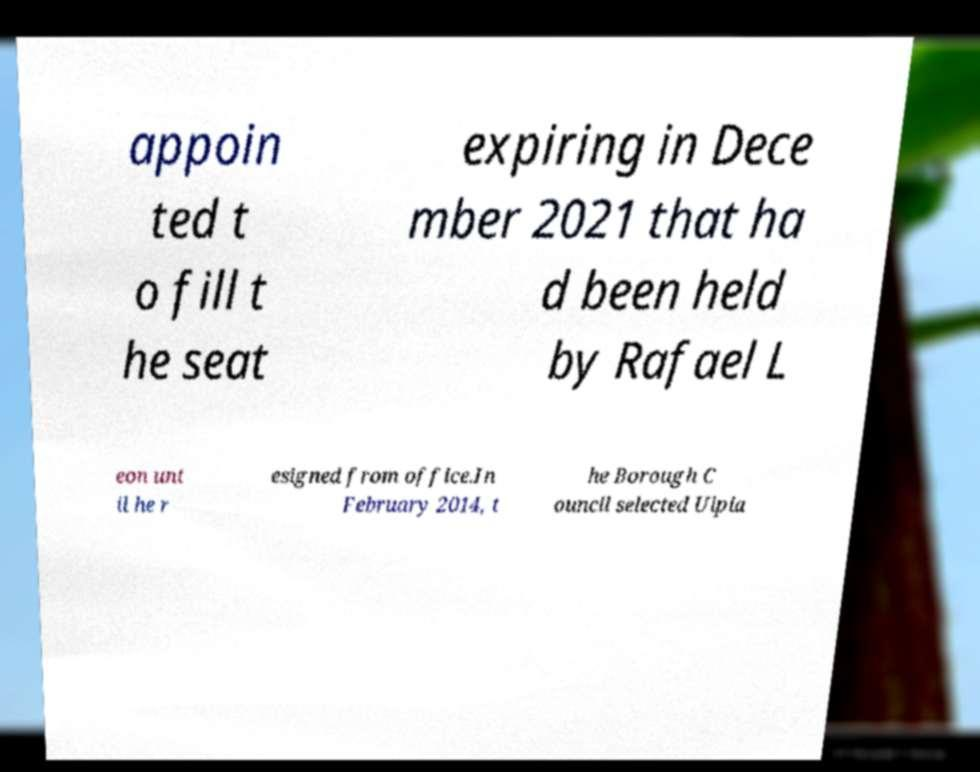Could you assist in decoding the text presented in this image and type it out clearly? appoin ted t o fill t he seat expiring in Dece mber 2021 that ha d been held by Rafael L eon unt il he r esigned from office.In February 2014, t he Borough C ouncil selected Ulpia 